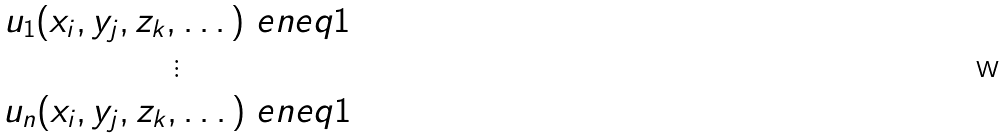Convert formula to latex. <formula><loc_0><loc_0><loc_500><loc_500>\begin{matrix} u _ { 1 } ( x _ { i } , y _ { j } , z _ { k } , \dots ) \ e n e q 1 \\ \vdots \\ u _ { n } ( x _ { i } , y _ { j } , z _ { k } , \dots ) \ e n e q 1 \end{matrix}</formula> 